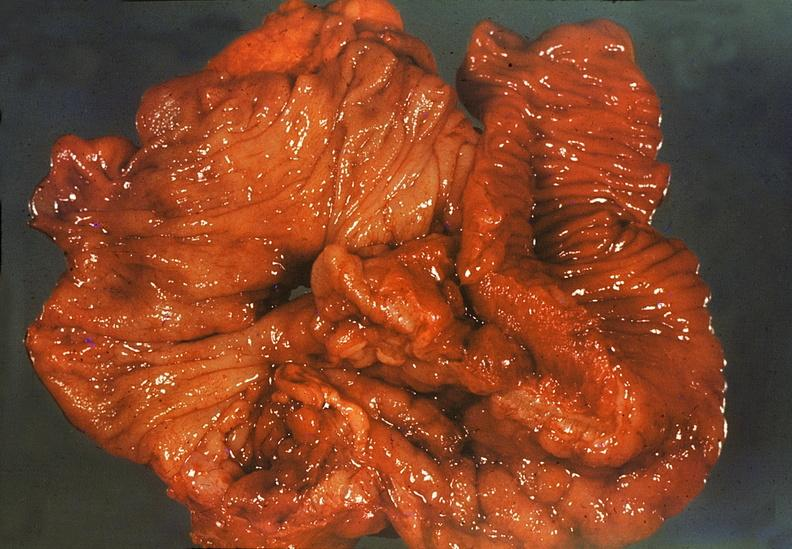s gastrointestinal present?
Answer the question using a single word or phrase. Yes 